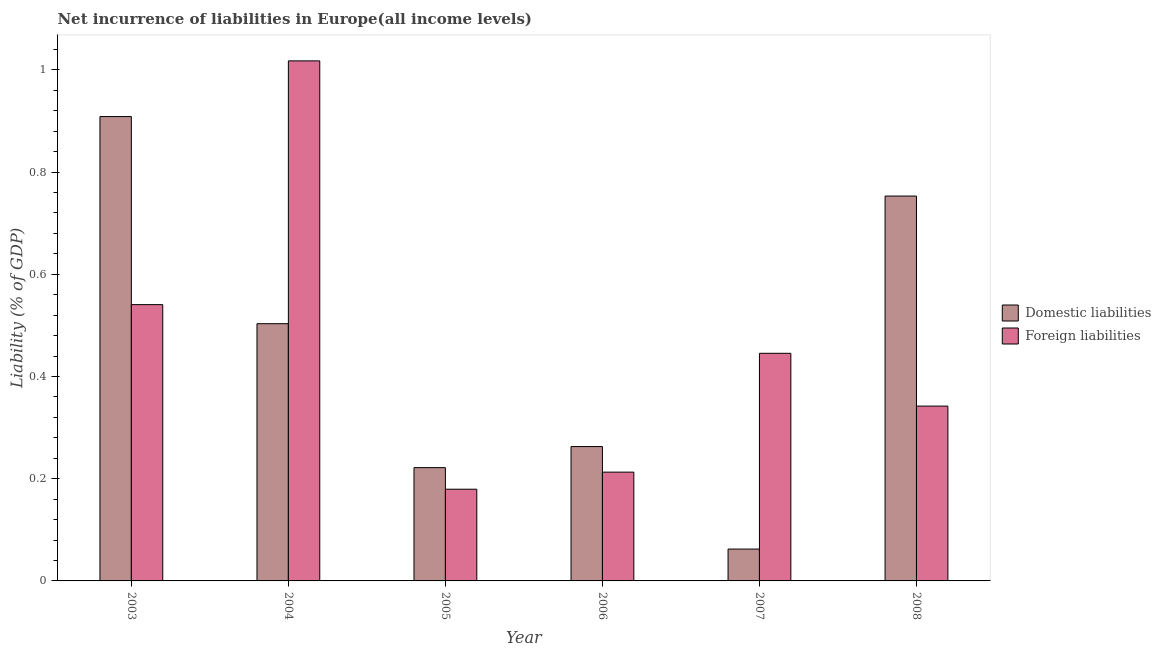How many different coloured bars are there?
Make the answer very short. 2. How many groups of bars are there?
Provide a short and direct response. 6. Are the number of bars on each tick of the X-axis equal?
Your answer should be very brief. Yes. How many bars are there on the 1st tick from the left?
Provide a succinct answer. 2. What is the label of the 1st group of bars from the left?
Your answer should be very brief. 2003. In how many cases, is the number of bars for a given year not equal to the number of legend labels?
Your answer should be compact. 0. What is the incurrence of domestic liabilities in 2007?
Offer a terse response. 0.06. Across all years, what is the maximum incurrence of domestic liabilities?
Offer a very short reply. 0.91. Across all years, what is the minimum incurrence of domestic liabilities?
Your answer should be very brief. 0.06. In which year was the incurrence of domestic liabilities maximum?
Your answer should be very brief. 2003. What is the total incurrence of foreign liabilities in the graph?
Your response must be concise. 2.74. What is the difference between the incurrence of domestic liabilities in 2003 and that in 2008?
Offer a very short reply. 0.16. What is the difference between the incurrence of domestic liabilities in 2008 and the incurrence of foreign liabilities in 2003?
Keep it short and to the point. -0.16. What is the average incurrence of domestic liabilities per year?
Keep it short and to the point. 0.45. In the year 2005, what is the difference between the incurrence of foreign liabilities and incurrence of domestic liabilities?
Your answer should be compact. 0. In how many years, is the incurrence of foreign liabilities greater than 0.52 %?
Offer a very short reply. 2. What is the ratio of the incurrence of foreign liabilities in 2005 to that in 2008?
Your response must be concise. 0.52. Is the incurrence of foreign liabilities in 2004 less than that in 2005?
Offer a very short reply. No. Is the difference between the incurrence of domestic liabilities in 2004 and 2008 greater than the difference between the incurrence of foreign liabilities in 2004 and 2008?
Provide a succinct answer. No. What is the difference between the highest and the second highest incurrence of domestic liabilities?
Your answer should be very brief. 0.16. What is the difference between the highest and the lowest incurrence of domestic liabilities?
Your response must be concise. 0.85. In how many years, is the incurrence of domestic liabilities greater than the average incurrence of domestic liabilities taken over all years?
Give a very brief answer. 3. Is the sum of the incurrence of foreign liabilities in 2003 and 2006 greater than the maximum incurrence of domestic liabilities across all years?
Make the answer very short. No. What does the 2nd bar from the left in 2007 represents?
Provide a short and direct response. Foreign liabilities. What does the 2nd bar from the right in 2008 represents?
Keep it short and to the point. Domestic liabilities. What is the difference between two consecutive major ticks on the Y-axis?
Provide a short and direct response. 0.2. Are the values on the major ticks of Y-axis written in scientific E-notation?
Offer a terse response. No. Where does the legend appear in the graph?
Your response must be concise. Center right. How are the legend labels stacked?
Provide a short and direct response. Vertical. What is the title of the graph?
Your answer should be compact. Net incurrence of liabilities in Europe(all income levels). Does "Exports of goods" appear as one of the legend labels in the graph?
Give a very brief answer. No. What is the label or title of the Y-axis?
Make the answer very short. Liability (% of GDP). What is the Liability (% of GDP) of Domestic liabilities in 2003?
Make the answer very short. 0.91. What is the Liability (% of GDP) of Foreign liabilities in 2003?
Keep it short and to the point. 0.54. What is the Liability (% of GDP) in Domestic liabilities in 2004?
Your response must be concise. 0.5. What is the Liability (% of GDP) in Foreign liabilities in 2004?
Provide a succinct answer. 1.02. What is the Liability (% of GDP) of Domestic liabilities in 2005?
Your response must be concise. 0.22. What is the Liability (% of GDP) in Foreign liabilities in 2005?
Give a very brief answer. 0.18. What is the Liability (% of GDP) of Domestic liabilities in 2006?
Your answer should be very brief. 0.26. What is the Liability (% of GDP) in Foreign liabilities in 2006?
Make the answer very short. 0.21. What is the Liability (% of GDP) in Domestic liabilities in 2007?
Provide a short and direct response. 0.06. What is the Liability (% of GDP) in Foreign liabilities in 2007?
Provide a short and direct response. 0.45. What is the Liability (% of GDP) in Domestic liabilities in 2008?
Make the answer very short. 0.75. What is the Liability (% of GDP) in Foreign liabilities in 2008?
Offer a terse response. 0.34. Across all years, what is the maximum Liability (% of GDP) in Domestic liabilities?
Offer a terse response. 0.91. Across all years, what is the maximum Liability (% of GDP) in Foreign liabilities?
Offer a terse response. 1.02. Across all years, what is the minimum Liability (% of GDP) of Domestic liabilities?
Offer a very short reply. 0.06. Across all years, what is the minimum Liability (% of GDP) in Foreign liabilities?
Your answer should be compact. 0.18. What is the total Liability (% of GDP) of Domestic liabilities in the graph?
Give a very brief answer. 2.71. What is the total Liability (% of GDP) of Foreign liabilities in the graph?
Offer a terse response. 2.74. What is the difference between the Liability (% of GDP) in Domestic liabilities in 2003 and that in 2004?
Ensure brevity in your answer.  0.41. What is the difference between the Liability (% of GDP) in Foreign liabilities in 2003 and that in 2004?
Provide a succinct answer. -0.48. What is the difference between the Liability (% of GDP) of Domestic liabilities in 2003 and that in 2005?
Provide a short and direct response. 0.69. What is the difference between the Liability (% of GDP) in Foreign liabilities in 2003 and that in 2005?
Give a very brief answer. 0.36. What is the difference between the Liability (% of GDP) in Domestic liabilities in 2003 and that in 2006?
Ensure brevity in your answer.  0.65. What is the difference between the Liability (% of GDP) in Foreign liabilities in 2003 and that in 2006?
Offer a very short reply. 0.33. What is the difference between the Liability (% of GDP) in Domestic liabilities in 2003 and that in 2007?
Provide a short and direct response. 0.85. What is the difference between the Liability (% of GDP) in Foreign liabilities in 2003 and that in 2007?
Offer a very short reply. 0.1. What is the difference between the Liability (% of GDP) of Domestic liabilities in 2003 and that in 2008?
Your answer should be very brief. 0.16. What is the difference between the Liability (% of GDP) in Foreign liabilities in 2003 and that in 2008?
Your answer should be very brief. 0.2. What is the difference between the Liability (% of GDP) in Domestic liabilities in 2004 and that in 2005?
Your response must be concise. 0.28. What is the difference between the Liability (% of GDP) of Foreign liabilities in 2004 and that in 2005?
Give a very brief answer. 0.84. What is the difference between the Liability (% of GDP) in Domestic liabilities in 2004 and that in 2006?
Ensure brevity in your answer.  0.24. What is the difference between the Liability (% of GDP) of Foreign liabilities in 2004 and that in 2006?
Offer a terse response. 0.8. What is the difference between the Liability (% of GDP) in Domestic liabilities in 2004 and that in 2007?
Keep it short and to the point. 0.44. What is the difference between the Liability (% of GDP) in Foreign liabilities in 2004 and that in 2007?
Your response must be concise. 0.57. What is the difference between the Liability (% of GDP) in Domestic liabilities in 2004 and that in 2008?
Your answer should be compact. -0.25. What is the difference between the Liability (% of GDP) of Foreign liabilities in 2004 and that in 2008?
Offer a terse response. 0.68. What is the difference between the Liability (% of GDP) of Domestic liabilities in 2005 and that in 2006?
Ensure brevity in your answer.  -0.04. What is the difference between the Liability (% of GDP) in Foreign liabilities in 2005 and that in 2006?
Ensure brevity in your answer.  -0.03. What is the difference between the Liability (% of GDP) of Domestic liabilities in 2005 and that in 2007?
Provide a succinct answer. 0.16. What is the difference between the Liability (% of GDP) of Foreign liabilities in 2005 and that in 2007?
Give a very brief answer. -0.27. What is the difference between the Liability (% of GDP) in Domestic liabilities in 2005 and that in 2008?
Make the answer very short. -0.53. What is the difference between the Liability (% of GDP) in Foreign liabilities in 2005 and that in 2008?
Offer a terse response. -0.16. What is the difference between the Liability (% of GDP) in Domestic liabilities in 2006 and that in 2007?
Make the answer very short. 0.2. What is the difference between the Liability (% of GDP) of Foreign liabilities in 2006 and that in 2007?
Provide a succinct answer. -0.23. What is the difference between the Liability (% of GDP) in Domestic liabilities in 2006 and that in 2008?
Your answer should be compact. -0.49. What is the difference between the Liability (% of GDP) in Foreign liabilities in 2006 and that in 2008?
Provide a short and direct response. -0.13. What is the difference between the Liability (% of GDP) of Domestic liabilities in 2007 and that in 2008?
Your answer should be compact. -0.69. What is the difference between the Liability (% of GDP) in Foreign liabilities in 2007 and that in 2008?
Offer a terse response. 0.1. What is the difference between the Liability (% of GDP) of Domestic liabilities in 2003 and the Liability (% of GDP) of Foreign liabilities in 2004?
Ensure brevity in your answer.  -0.11. What is the difference between the Liability (% of GDP) of Domestic liabilities in 2003 and the Liability (% of GDP) of Foreign liabilities in 2005?
Your answer should be compact. 0.73. What is the difference between the Liability (% of GDP) in Domestic liabilities in 2003 and the Liability (% of GDP) in Foreign liabilities in 2006?
Offer a very short reply. 0.7. What is the difference between the Liability (% of GDP) of Domestic liabilities in 2003 and the Liability (% of GDP) of Foreign liabilities in 2007?
Your response must be concise. 0.46. What is the difference between the Liability (% of GDP) of Domestic liabilities in 2003 and the Liability (% of GDP) of Foreign liabilities in 2008?
Offer a very short reply. 0.57. What is the difference between the Liability (% of GDP) of Domestic liabilities in 2004 and the Liability (% of GDP) of Foreign liabilities in 2005?
Keep it short and to the point. 0.32. What is the difference between the Liability (% of GDP) in Domestic liabilities in 2004 and the Liability (% of GDP) in Foreign liabilities in 2006?
Keep it short and to the point. 0.29. What is the difference between the Liability (% of GDP) of Domestic liabilities in 2004 and the Liability (% of GDP) of Foreign liabilities in 2007?
Give a very brief answer. 0.06. What is the difference between the Liability (% of GDP) in Domestic liabilities in 2004 and the Liability (% of GDP) in Foreign liabilities in 2008?
Offer a very short reply. 0.16. What is the difference between the Liability (% of GDP) of Domestic liabilities in 2005 and the Liability (% of GDP) of Foreign liabilities in 2006?
Your answer should be compact. 0.01. What is the difference between the Liability (% of GDP) in Domestic liabilities in 2005 and the Liability (% of GDP) in Foreign liabilities in 2007?
Offer a terse response. -0.22. What is the difference between the Liability (% of GDP) in Domestic liabilities in 2005 and the Liability (% of GDP) in Foreign liabilities in 2008?
Your answer should be compact. -0.12. What is the difference between the Liability (% of GDP) in Domestic liabilities in 2006 and the Liability (% of GDP) in Foreign liabilities in 2007?
Give a very brief answer. -0.18. What is the difference between the Liability (% of GDP) in Domestic liabilities in 2006 and the Liability (% of GDP) in Foreign liabilities in 2008?
Your answer should be compact. -0.08. What is the difference between the Liability (% of GDP) in Domestic liabilities in 2007 and the Liability (% of GDP) in Foreign liabilities in 2008?
Your answer should be compact. -0.28. What is the average Liability (% of GDP) in Domestic liabilities per year?
Keep it short and to the point. 0.45. What is the average Liability (% of GDP) in Foreign liabilities per year?
Your answer should be very brief. 0.46. In the year 2003, what is the difference between the Liability (% of GDP) of Domestic liabilities and Liability (% of GDP) of Foreign liabilities?
Ensure brevity in your answer.  0.37. In the year 2004, what is the difference between the Liability (% of GDP) in Domestic liabilities and Liability (% of GDP) in Foreign liabilities?
Ensure brevity in your answer.  -0.51. In the year 2005, what is the difference between the Liability (% of GDP) of Domestic liabilities and Liability (% of GDP) of Foreign liabilities?
Make the answer very short. 0.04. In the year 2007, what is the difference between the Liability (% of GDP) of Domestic liabilities and Liability (% of GDP) of Foreign liabilities?
Provide a short and direct response. -0.38. In the year 2008, what is the difference between the Liability (% of GDP) in Domestic liabilities and Liability (% of GDP) in Foreign liabilities?
Your answer should be compact. 0.41. What is the ratio of the Liability (% of GDP) in Domestic liabilities in 2003 to that in 2004?
Your answer should be compact. 1.81. What is the ratio of the Liability (% of GDP) of Foreign liabilities in 2003 to that in 2004?
Give a very brief answer. 0.53. What is the ratio of the Liability (% of GDP) of Domestic liabilities in 2003 to that in 2005?
Give a very brief answer. 4.1. What is the ratio of the Liability (% of GDP) of Foreign liabilities in 2003 to that in 2005?
Provide a succinct answer. 3.01. What is the ratio of the Liability (% of GDP) of Domestic liabilities in 2003 to that in 2006?
Your response must be concise. 3.46. What is the ratio of the Liability (% of GDP) in Foreign liabilities in 2003 to that in 2006?
Ensure brevity in your answer.  2.54. What is the ratio of the Liability (% of GDP) in Domestic liabilities in 2003 to that in 2007?
Your answer should be very brief. 14.58. What is the ratio of the Liability (% of GDP) of Foreign liabilities in 2003 to that in 2007?
Ensure brevity in your answer.  1.21. What is the ratio of the Liability (% of GDP) of Domestic liabilities in 2003 to that in 2008?
Ensure brevity in your answer.  1.21. What is the ratio of the Liability (% of GDP) of Foreign liabilities in 2003 to that in 2008?
Provide a succinct answer. 1.58. What is the ratio of the Liability (% of GDP) of Domestic liabilities in 2004 to that in 2005?
Offer a terse response. 2.27. What is the ratio of the Liability (% of GDP) in Foreign liabilities in 2004 to that in 2005?
Your response must be concise. 5.67. What is the ratio of the Liability (% of GDP) of Domestic liabilities in 2004 to that in 2006?
Your answer should be compact. 1.91. What is the ratio of the Liability (% of GDP) in Foreign liabilities in 2004 to that in 2006?
Offer a terse response. 4.78. What is the ratio of the Liability (% of GDP) in Domestic liabilities in 2004 to that in 2007?
Make the answer very short. 8.08. What is the ratio of the Liability (% of GDP) of Foreign liabilities in 2004 to that in 2007?
Ensure brevity in your answer.  2.28. What is the ratio of the Liability (% of GDP) of Domestic liabilities in 2004 to that in 2008?
Provide a short and direct response. 0.67. What is the ratio of the Liability (% of GDP) of Foreign liabilities in 2004 to that in 2008?
Offer a very short reply. 2.97. What is the ratio of the Liability (% of GDP) of Domestic liabilities in 2005 to that in 2006?
Your response must be concise. 0.84. What is the ratio of the Liability (% of GDP) in Foreign liabilities in 2005 to that in 2006?
Provide a short and direct response. 0.84. What is the ratio of the Liability (% of GDP) in Domestic liabilities in 2005 to that in 2007?
Offer a very short reply. 3.56. What is the ratio of the Liability (% of GDP) in Foreign liabilities in 2005 to that in 2007?
Offer a very short reply. 0.4. What is the ratio of the Liability (% of GDP) of Domestic liabilities in 2005 to that in 2008?
Provide a short and direct response. 0.29. What is the ratio of the Liability (% of GDP) of Foreign liabilities in 2005 to that in 2008?
Provide a short and direct response. 0.52. What is the ratio of the Liability (% of GDP) in Domestic liabilities in 2006 to that in 2007?
Give a very brief answer. 4.22. What is the ratio of the Liability (% of GDP) of Foreign liabilities in 2006 to that in 2007?
Ensure brevity in your answer.  0.48. What is the ratio of the Liability (% of GDP) of Domestic liabilities in 2006 to that in 2008?
Offer a very short reply. 0.35. What is the ratio of the Liability (% of GDP) in Foreign liabilities in 2006 to that in 2008?
Provide a succinct answer. 0.62. What is the ratio of the Liability (% of GDP) of Domestic liabilities in 2007 to that in 2008?
Provide a succinct answer. 0.08. What is the ratio of the Liability (% of GDP) in Foreign liabilities in 2007 to that in 2008?
Keep it short and to the point. 1.3. What is the difference between the highest and the second highest Liability (% of GDP) of Domestic liabilities?
Offer a very short reply. 0.16. What is the difference between the highest and the second highest Liability (% of GDP) in Foreign liabilities?
Provide a succinct answer. 0.48. What is the difference between the highest and the lowest Liability (% of GDP) of Domestic liabilities?
Make the answer very short. 0.85. What is the difference between the highest and the lowest Liability (% of GDP) in Foreign liabilities?
Your answer should be very brief. 0.84. 